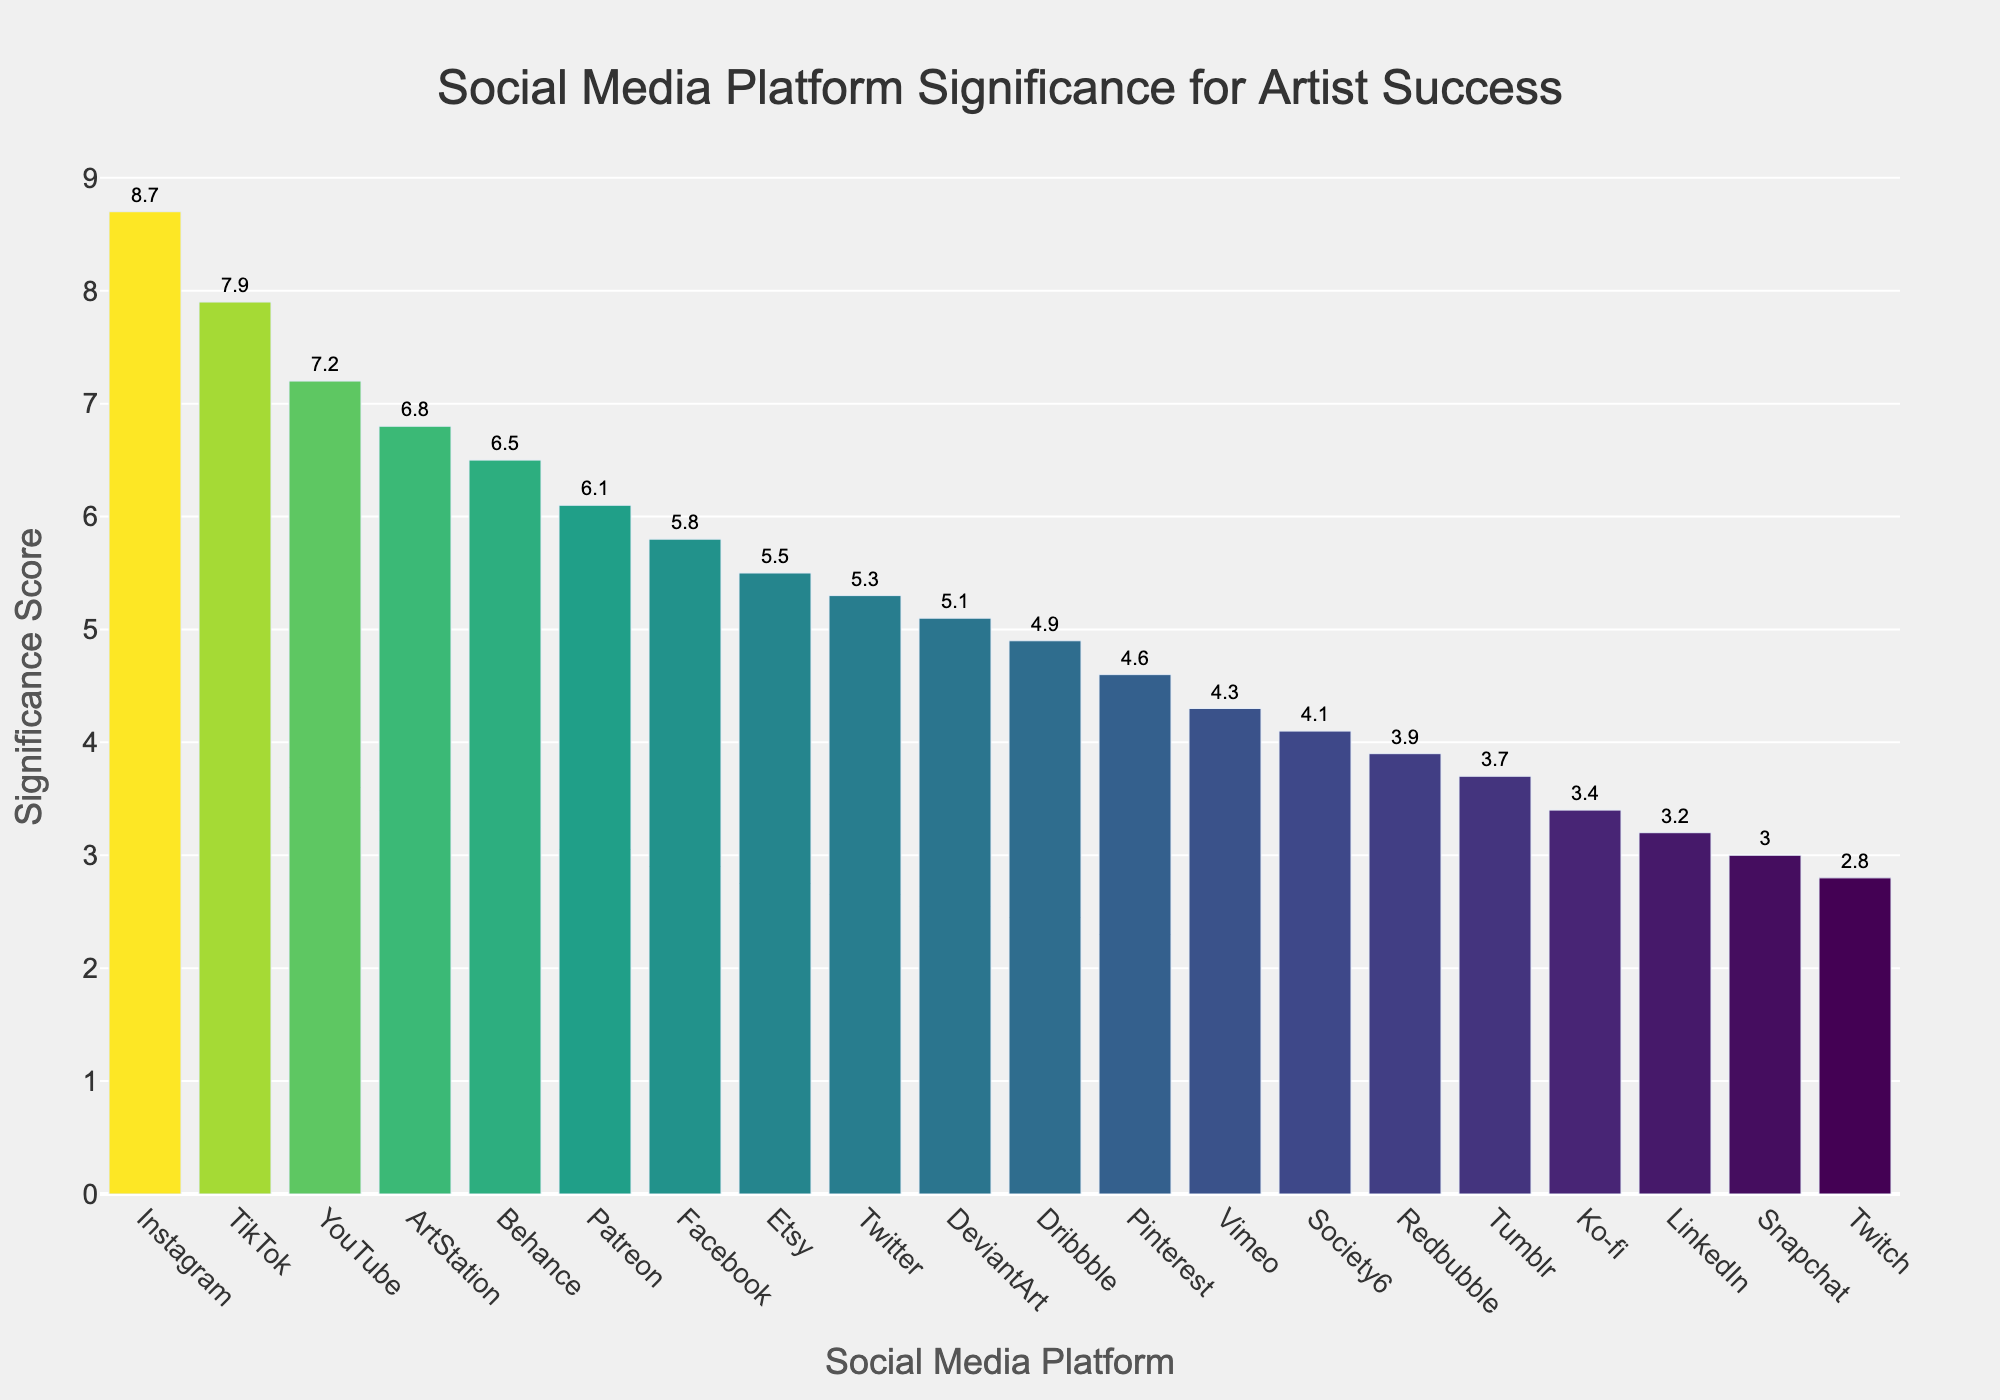Which social media platform has the highest significance score? The platform with the highest significance score is identified by visually looking for the tallest bar in the plot.
Answer: Instagram How many platforms have a significance score higher than 6? Count the number of bars that rise above the y-axis value of 6 in the plot.
Answer: 6 Which platforms have significance scores lower than 4? Identify the platforms represented by bars that do not reach a y-axis value of 4.
Answer: LinkedIn, Snapchat, Tumblr, Twitch, Ko-fi What is the significance score of YouTube and how does it compare to TikTok? Locate the bars for YouTube and TikTok, note their heights, and compare the y-axis values.
Answer: YouTube: 7.2, TikTok: 7.9. TikTok has a higher score What is the median significance score among all platforms? Arrange the significance scores in ascending order and find the middle value.
Answer: 5.3 Which platform is the least significant for artist success? Identify the platform represented by the shortest bar in the plot.
Answer: Twitch Calculate the average significance score of the top three platforms. Sum the significance scores of Instagram (8.7), TikTok (7.9), and YouTube (7.2) and divide by 3.
Answer: (8.7 + 7.9 + 7.2) / 3 = 7.93 Which has a higher significance score: Etsy or Pinterest? Compare the heights of the bars representing Etsy and Pinterest.
Answer: Etsy Are Pinterest and LinkedIn close in their significance scores? Compare the heights of the bars for Pinterest (4.6) and LinkedIn (3.2) to see how close they are.
Answer: No How does ArtStation compare to Behance in terms of significance score? Compare the heights of the bars for ArtStation and Behance.
Answer: ArtStation: 6.8, Behance: 6.5. ArtStation has a slightly higher score 